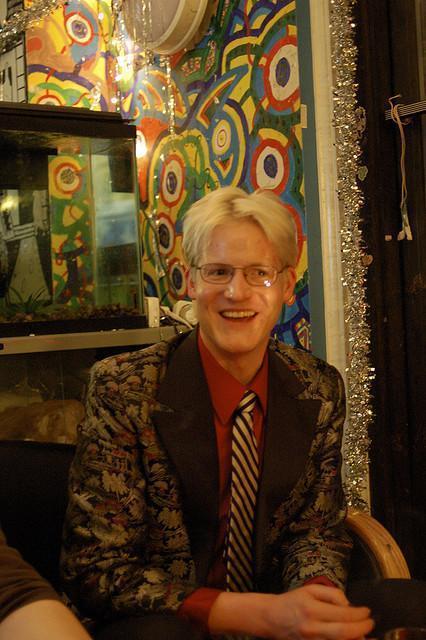How many train cars are orange?
Give a very brief answer. 0. 